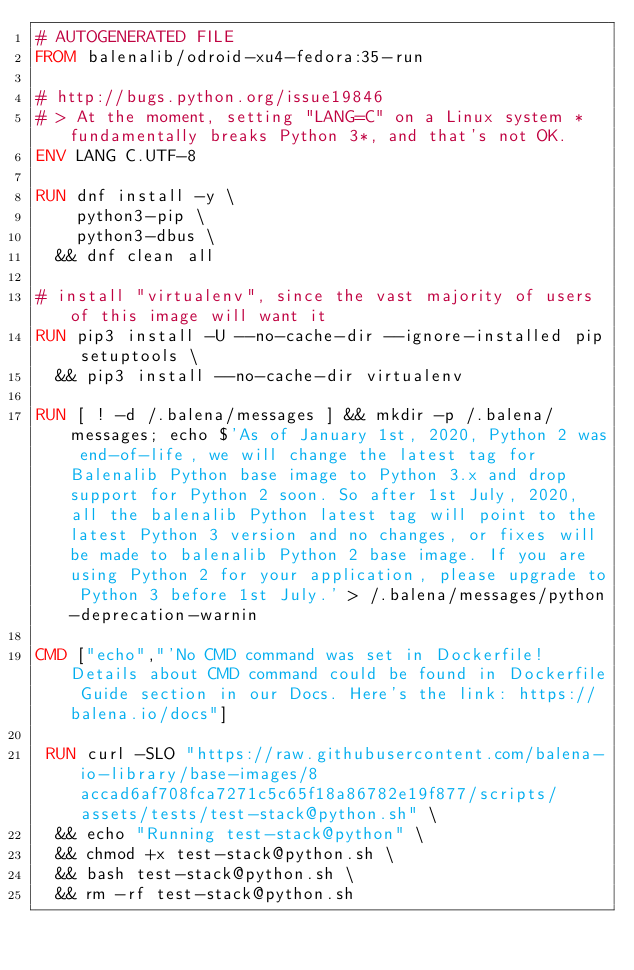Convert code to text. <code><loc_0><loc_0><loc_500><loc_500><_Dockerfile_># AUTOGENERATED FILE
FROM balenalib/odroid-xu4-fedora:35-run

# http://bugs.python.org/issue19846
# > At the moment, setting "LANG=C" on a Linux system *fundamentally breaks Python 3*, and that's not OK.
ENV LANG C.UTF-8

RUN dnf install -y \
		python3-pip \
		python3-dbus \
	&& dnf clean all

# install "virtualenv", since the vast majority of users of this image will want it
RUN pip3 install -U --no-cache-dir --ignore-installed pip setuptools \
	&& pip3 install --no-cache-dir virtualenv

RUN [ ! -d /.balena/messages ] && mkdir -p /.balena/messages; echo $'As of January 1st, 2020, Python 2 was end-of-life, we will change the latest tag for Balenalib Python base image to Python 3.x and drop support for Python 2 soon. So after 1st July, 2020, all the balenalib Python latest tag will point to the latest Python 3 version and no changes, or fixes will be made to balenalib Python 2 base image. If you are using Python 2 for your application, please upgrade to Python 3 before 1st July.' > /.balena/messages/python-deprecation-warnin

CMD ["echo","'No CMD command was set in Dockerfile! Details about CMD command could be found in Dockerfile Guide section in our Docs. Here's the link: https://balena.io/docs"]

 RUN curl -SLO "https://raw.githubusercontent.com/balena-io-library/base-images/8accad6af708fca7271c5c65f18a86782e19f877/scripts/assets/tests/test-stack@python.sh" \
  && echo "Running test-stack@python" \
  && chmod +x test-stack@python.sh \
  && bash test-stack@python.sh \
  && rm -rf test-stack@python.sh 
</code> 